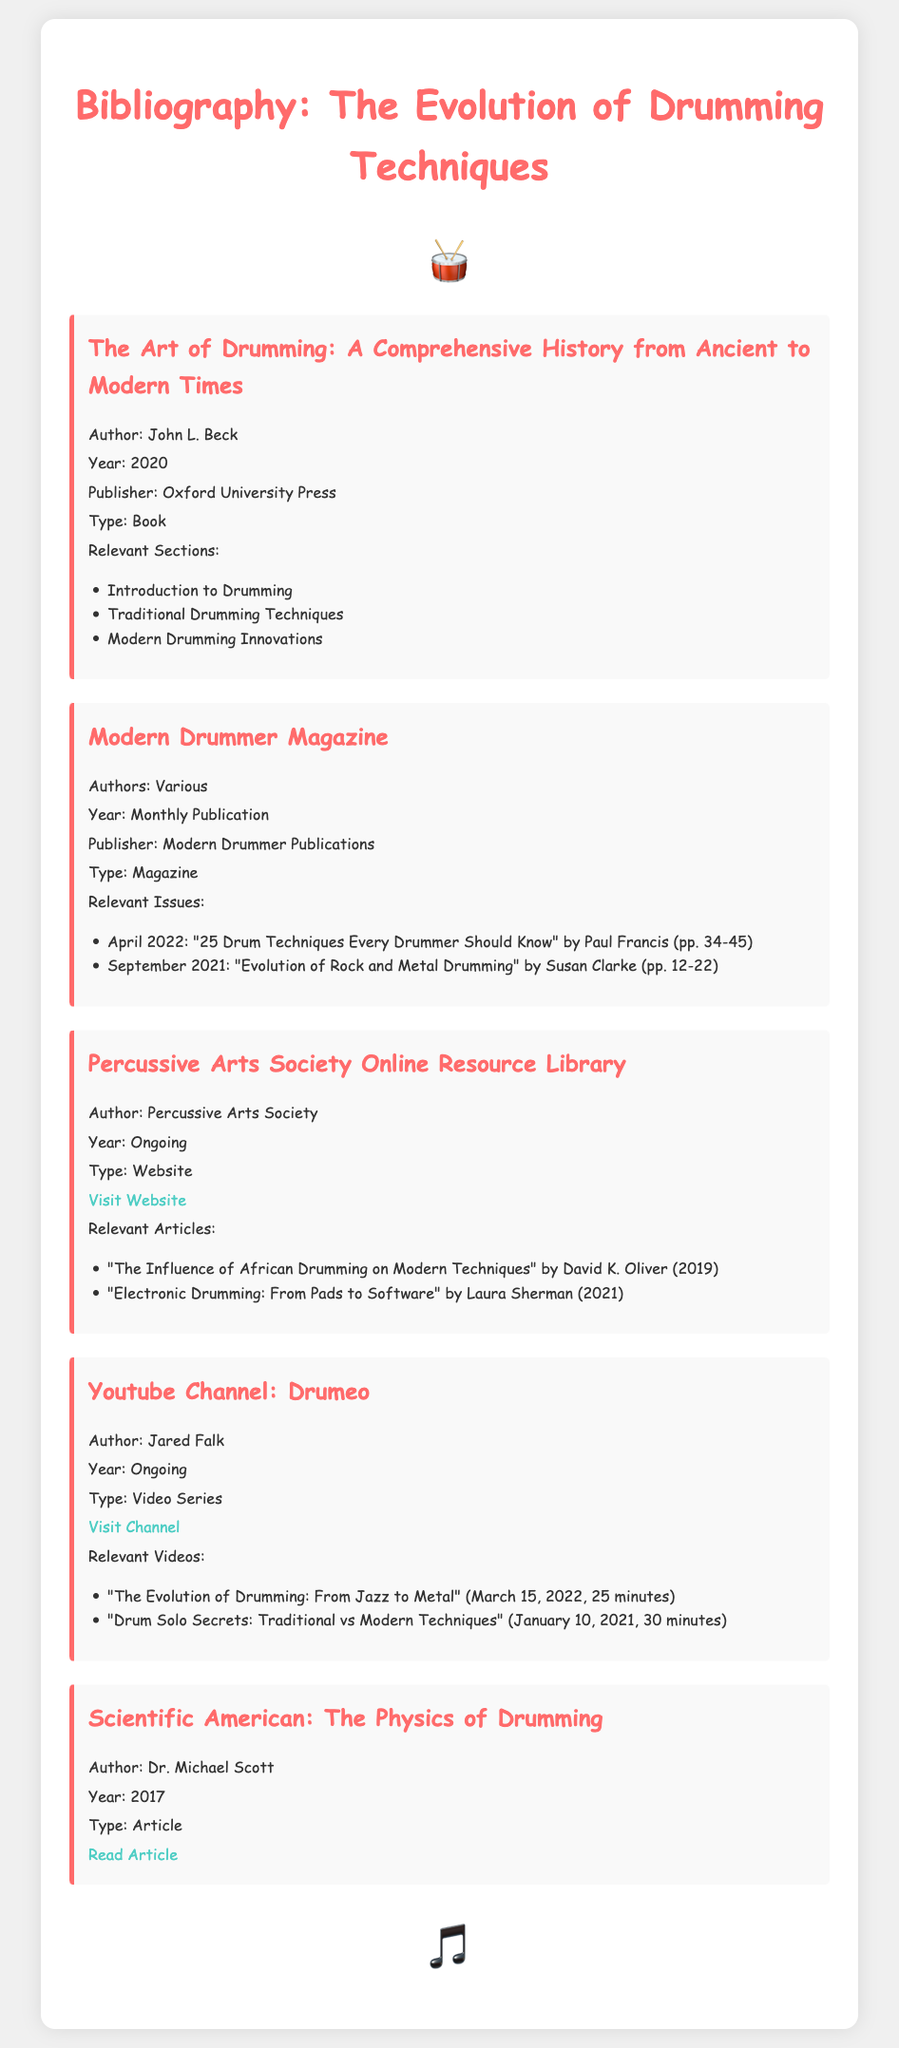What is the title of the first source? The title is located in the first source section of the bibliography.
Answer: The Art of Drumming: A Comprehensive History from Ancient to Modern Times Who is the author of the article in Scientific American? The author is mentioned at the beginning of the Scientific American article section.
Answer: Dr. Michael Scott What year was "Modern Drummer Magazine" published? The year is stated as "Monthly Publication" under the magazine section.
Answer: Monthly Publication What type of resource is the "Percussive Arts Society Online Resource Library"? The type is specified under the resource's details in the bibliography.
Answer: Website What is the main focus of the video titled "The Evolution of Drumming: From Jazz to Metal"? The focus is mentioned in the title of the video listed in the YouTube channel section.
Answer: From Jazz to Metal Which author wrote about electronic drumming in the online resource library? The author's name is provided in the relevant articles section under the online resource library.
Answer: Laura Sherman What year was "The Art of Drumming: A Comprehensive History from Ancient to Modern Times" published? The publication year is mentioned right after the author's name in the first source.
Answer: 2020 Which issue of Modern Drummer Magazine discusses the evolution of rock and metal drumming? This is found in the relevant issues list for the magazine.
Answer: September 2021 